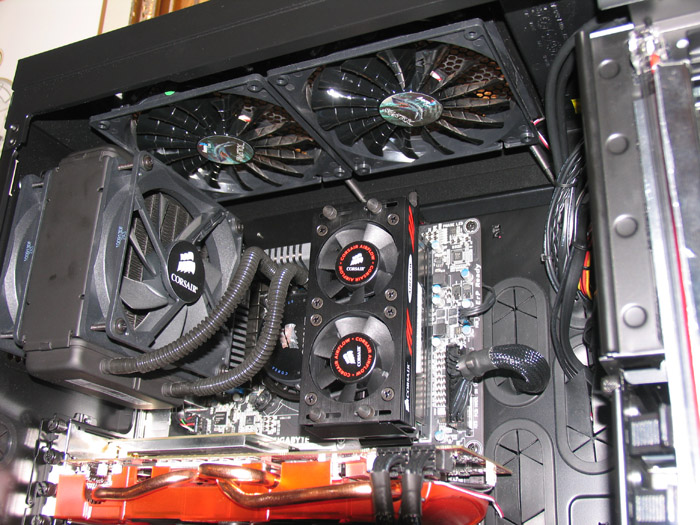Imagine if this computer was capable of running a cutting-edge AI program for space exploration. What kind of upgrades or additional components might be required? If this computer were to run a cutting-edge AI program for space exploration, several upgrades and additional components would be essential. For one, the system might benefit from additional GPUs and enhanced cooling solutions to manage the heat generated by multiple graphics cards. Upgrading the CPU to a more powerful model capable of handling significant computational loads would be crucial. The addition of more RAM would ensure smooth multitasking and handling of large data sets. Furthermore, incorporating high-speed NVMe SSDs would drastically improve data read/write speeds, thereby optimizing overall system performance. Enhancements in network connectivity with faster Ethernet or specialized hardware interfaces could also be essential for high-speed data transfer from space probes. Reliable power supplies with higher wattage and increased stability would further ensure consistent performance under heavy loads. 